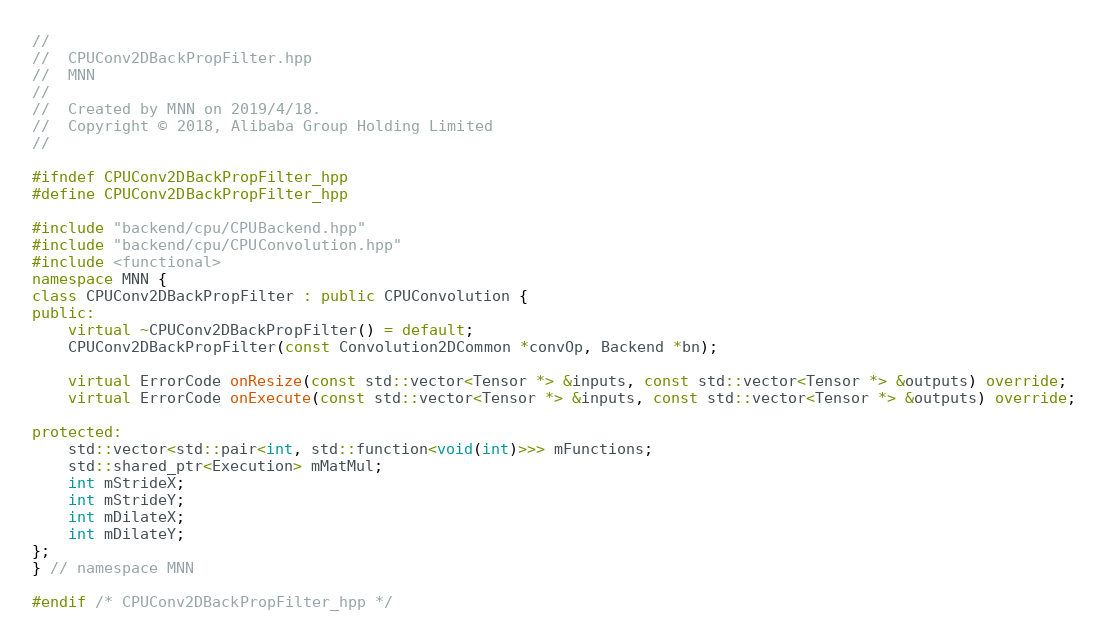<code> <loc_0><loc_0><loc_500><loc_500><_C++_>//
//  CPUConv2DBackPropFilter.hpp
//  MNN
//
//  Created by MNN on 2019/4/18.
//  Copyright © 2018, Alibaba Group Holding Limited
//

#ifndef CPUConv2DBackPropFilter_hpp
#define CPUConv2DBackPropFilter_hpp

#include "backend/cpu/CPUBackend.hpp"
#include "backend/cpu/CPUConvolution.hpp"
#include <functional>
namespace MNN {
class CPUConv2DBackPropFilter : public CPUConvolution {
public:
    virtual ~CPUConv2DBackPropFilter() = default;
    CPUConv2DBackPropFilter(const Convolution2DCommon *convOp, Backend *bn);

    virtual ErrorCode onResize(const std::vector<Tensor *> &inputs, const std::vector<Tensor *> &outputs) override;
    virtual ErrorCode onExecute(const std::vector<Tensor *> &inputs, const std::vector<Tensor *> &outputs) override;

protected:
    std::vector<std::pair<int, std::function<void(int)>>> mFunctions;
    std::shared_ptr<Execution> mMatMul;
    int mStrideX;
    int mStrideY;
    int mDilateX;
    int mDilateY;
};
} // namespace MNN

#endif /* CPUConv2DBackPropFilter_hpp */
</code> 